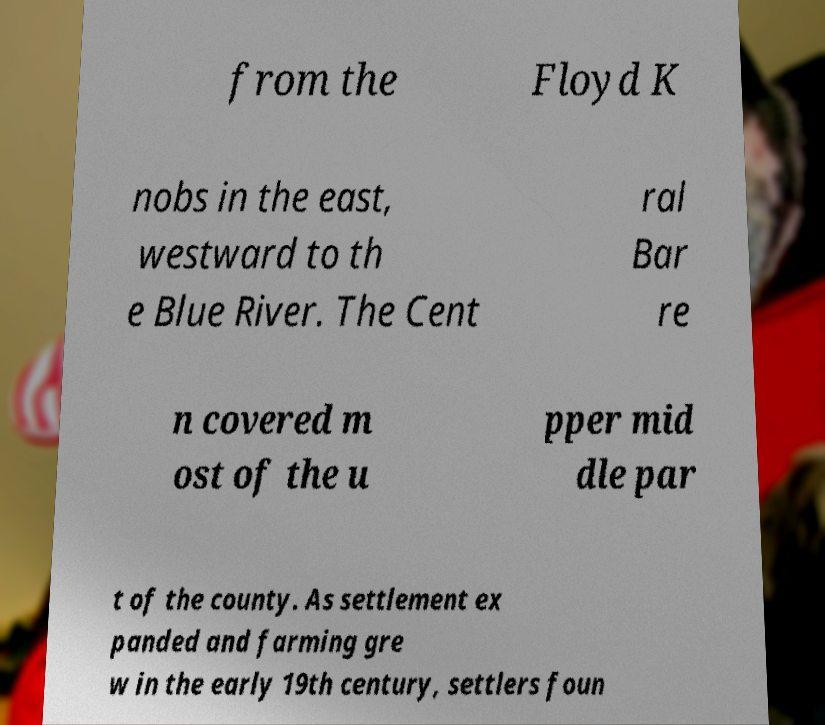Could you assist in decoding the text presented in this image and type it out clearly? from the Floyd K nobs in the east, westward to th e Blue River. The Cent ral Bar re n covered m ost of the u pper mid dle par t of the county. As settlement ex panded and farming gre w in the early 19th century, settlers foun 